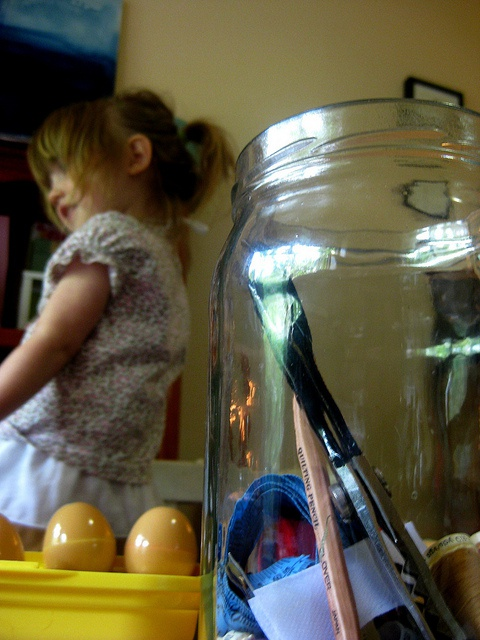Describe the objects in this image and their specific colors. I can see bottle in navy, black, darkgreen, gray, and white tones, people in navy, black, gray, and maroon tones, scissors in navy, black, ivory, gray, and lightblue tones, and bowl in navy, olive, and gold tones in this image. 